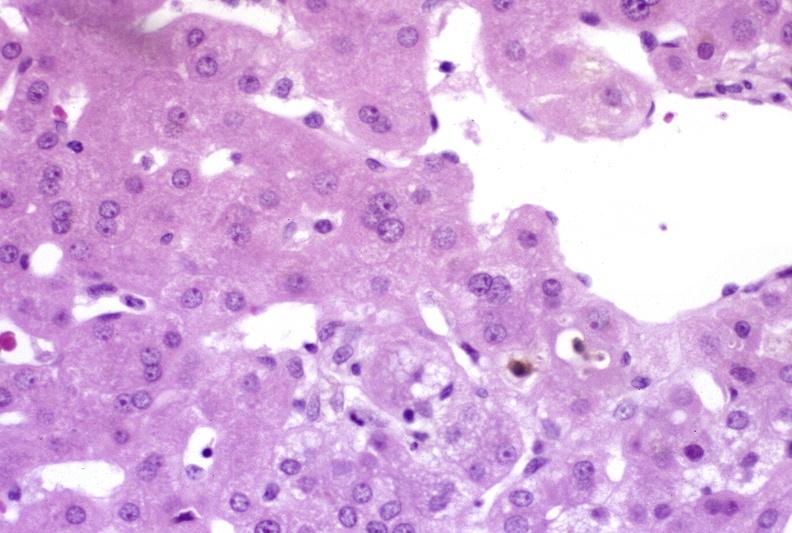does fracture show ductopenia?
Answer the question using a single word or phrase. No 